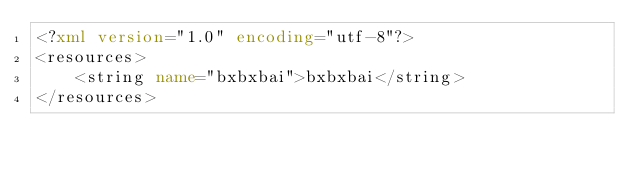<code> <loc_0><loc_0><loc_500><loc_500><_XML_><?xml version="1.0" encoding="utf-8"?>
<resources>
    <string name="bxbxbai">bxbxbai</string>
</resources></code> 